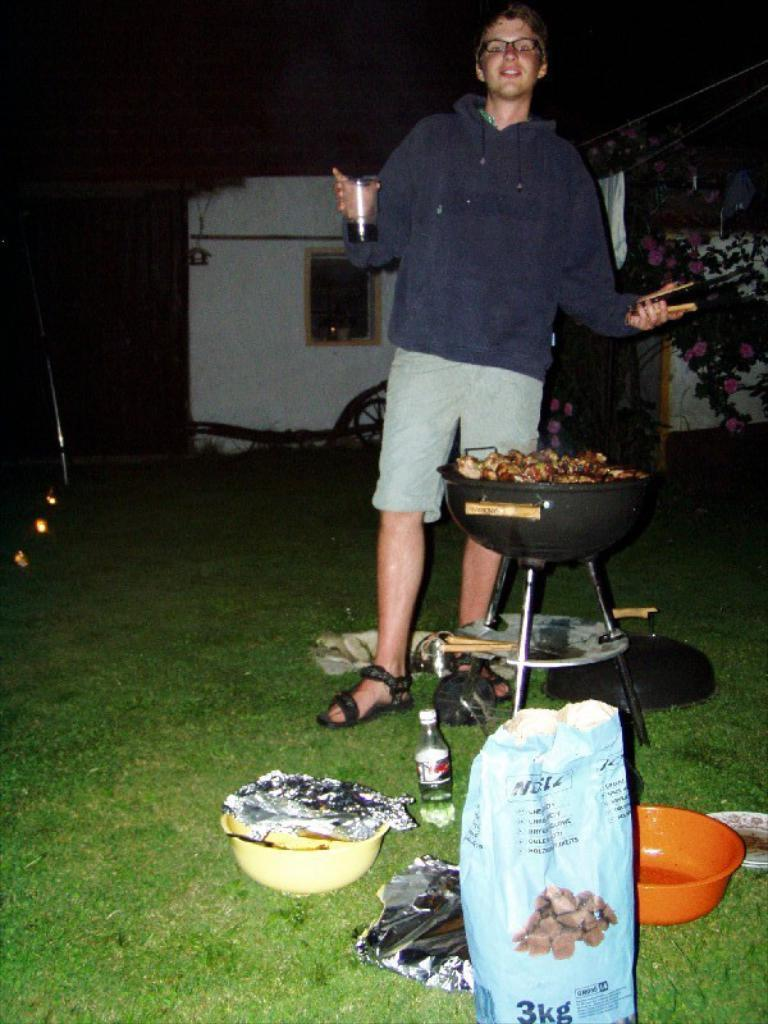<image>
Give a short and clear explanation of the subsequent image. a man standing in front of a 3 kg bag 